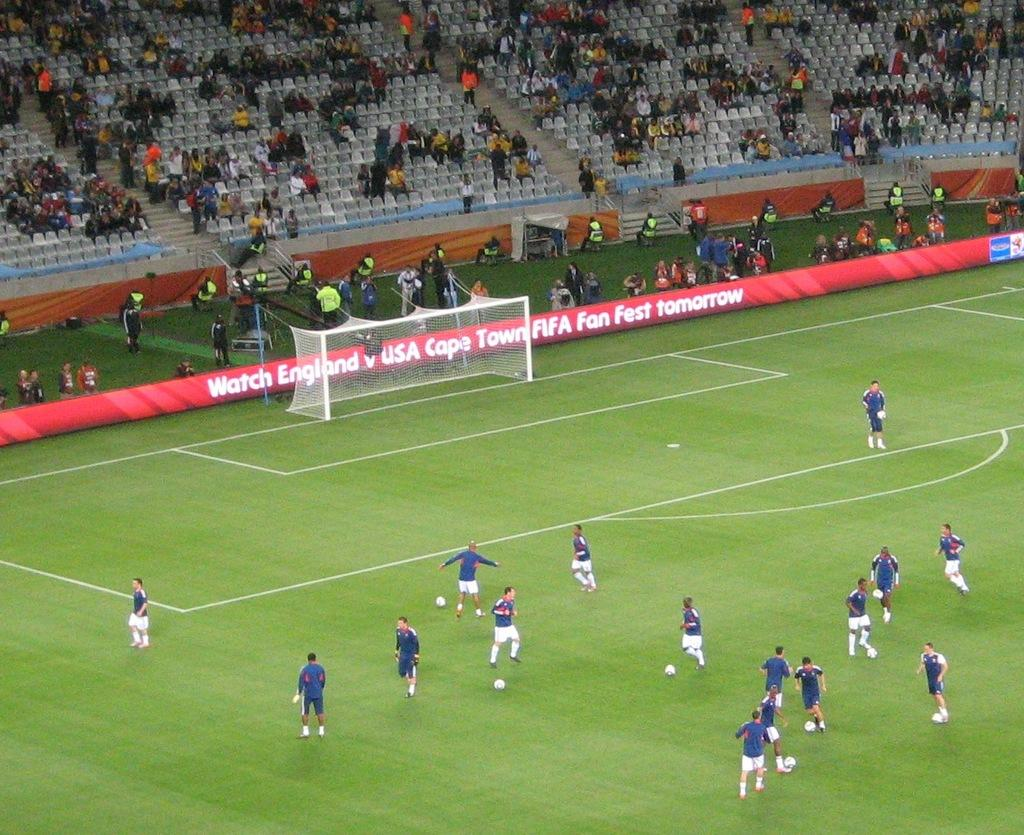<image>
Relay a brief, clear account of the picture shown. People playing soccer in a stadium that says "Watch England vs USA" on the side. 